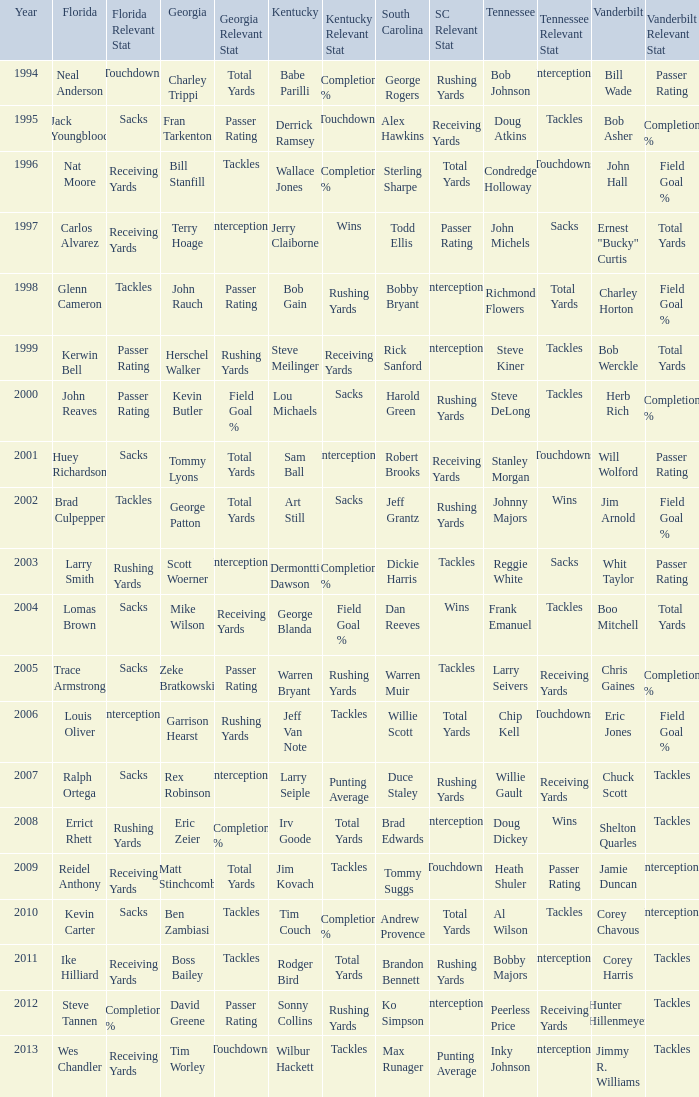What is the Tennessee that Georgia of kevin butler is in? Steve DeLong. 